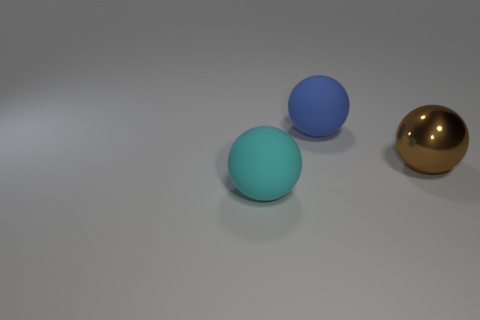Subtract all blue balls. How many balls are left? 2 Add 3 blue rubber objects. How many objects exist? 6 Subtract 1 blue spheres. How many objects are left? 2 Subtract all tiny yellow cylinders. Subtract all rubber balls. How many objects are left? 1 Add 3 big metallic spheres. How many big metallic spheres are left? 4 Add 3 small yellow metallic cylinders. How many small yellow metallic cylinders exist? 3 